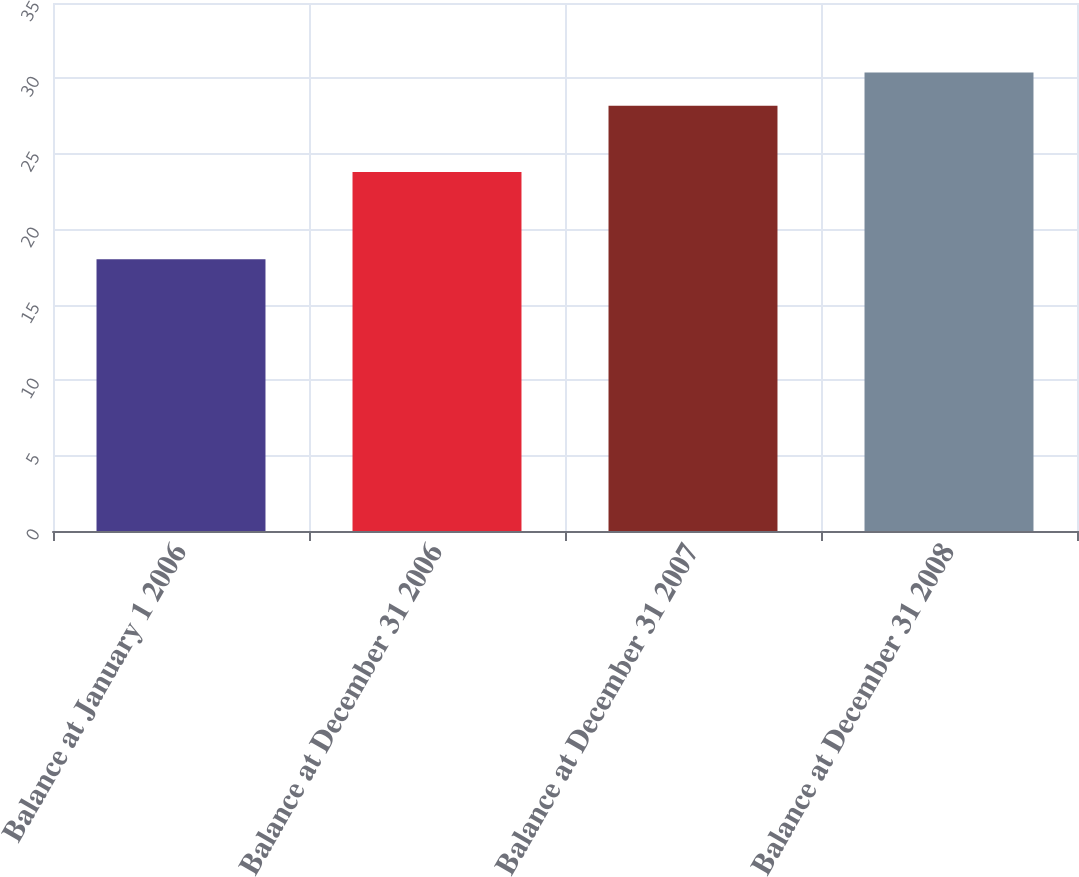<chart> <loc_0><loc_0><loc_500><loc_500><bar_chart><fcel>Balance at January 1 2006<fcel>Balance at December 31 2006<fcel>Balance at December 31 2007<fcel>Balance at December 31 2008<nl><fcel>18.01<fcel>23.8<fcel>28.19<fcel>30.39<nl></chart> 